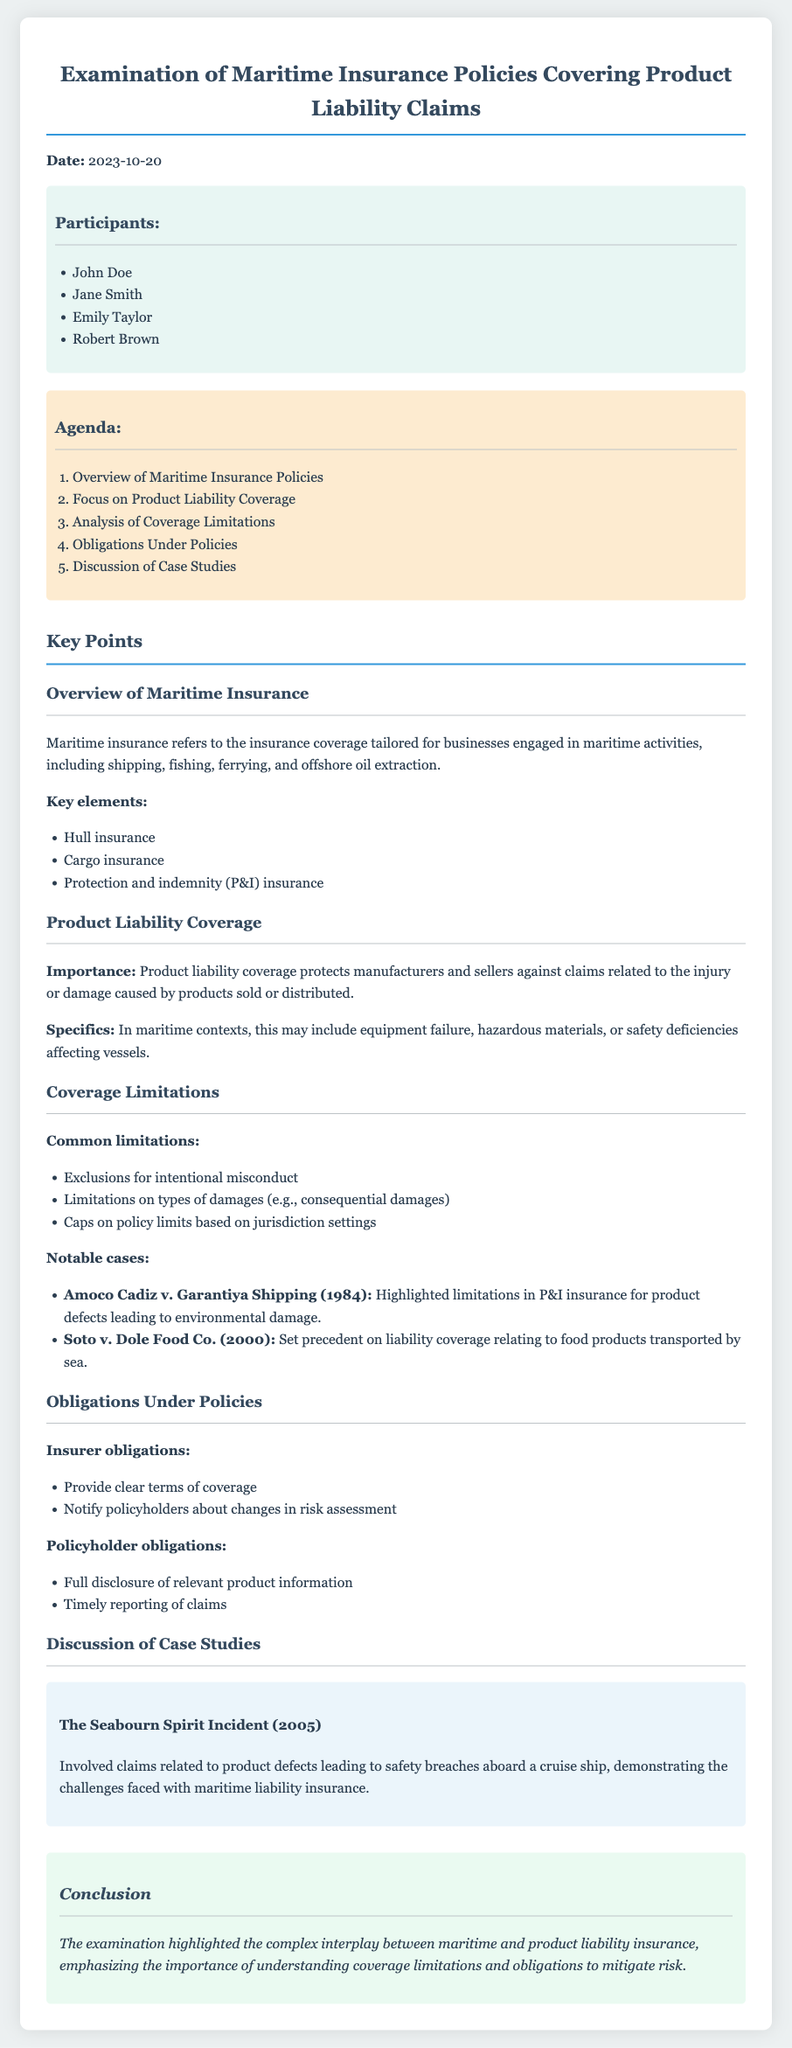What is the date of the meeting? The date of the meeting is explicitly stated in the document as 2023-10-20.
Answer: 2023-10-20 Who is one of the participants listed? The document contains a list of participants, one of whom is John Doe.
Answer: John Doe What is a key element of maritime insurance mentioned? The document specifies that hull insurance is a key element of maritime insurance.
Answer: Hull insurance What is a common limitation in coverage? The document mentions exclusions for intentional misconduct as a common limitation in coverage.
Answer: Exclusions for intentional misconduct What does the product liability coverage protect against? The document states that product liability coverage protects manufacturers and sellers against claims related to injury or damage caused by products sold or distributed.
Answer: Claims related to injury or damage caused by products sold or distributed What obligation do policyholders have according to the meeting minutes? The document outlines that policyholders have the obligation of full disclosure of relevant product information.
Answer: Full disclosure of relevant product information Which case highlighted limitations in P&I insurance? The document refers to Amoco Cadiz v. Garantiya Shipping (1984) as a case that highlighted limitations in P&I insurance for product defects.
Answer: Amoco Cadiz v. Garantiya Shipping (1984) What is the background color of the participants section? The document describes the background color of the participants section as light blue.
Answer: Light blue 